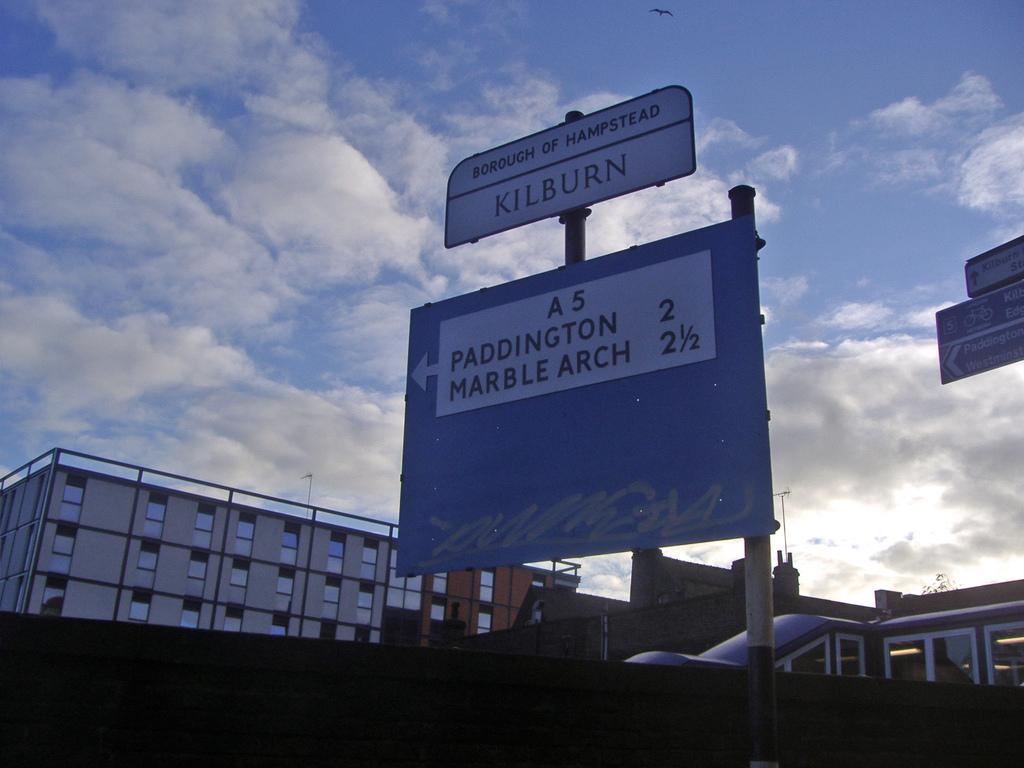What is the name of his borough?
Provide a short and direct response. Hampstead. What is the arch made of?
Keep it short and to the point. Marble. 